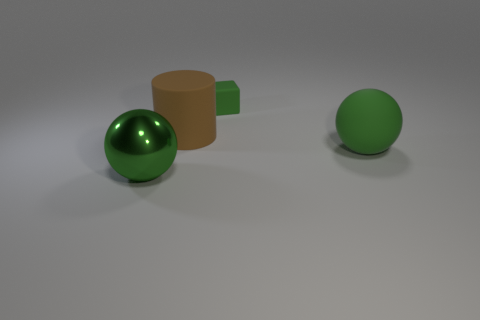The metal thing that is the same size as the brown cylinder is what color?
Your response must be concise. Green. Is the material of the ball on the right side of the cylinder the same as the cube?
Your response must be concise. Yes. Are there any green cubes that are in front of the big green thing that is left of the ball that is right of the rubber cube?
Offer a very short reply. No. Does the matte object that is right of the cube have the same shape as the brown rubber thing?
Ensure brevity in your answer.  No. What is the shape of the thing on the right side of the green object behind the large matte sphere?
Make the answer very short. Sphere. How big is the object that is behind the big matte thing on the left side of the big green sphere that is to the right of the large green metal ball?
Your answer should be compact. Small. What is the color of the other object that is the same shape as the green shiny thing?
Offer a terse response. Green. Does the cylinder have the same size as the cube?
Your answer should be compact. No. What is the material of the thing that is to the right of the green matte block?
Provide a short and direct response. Rubber. How many other objects are there of the same shape as the tiny green thing?
Your answer should be very brief. 0. 